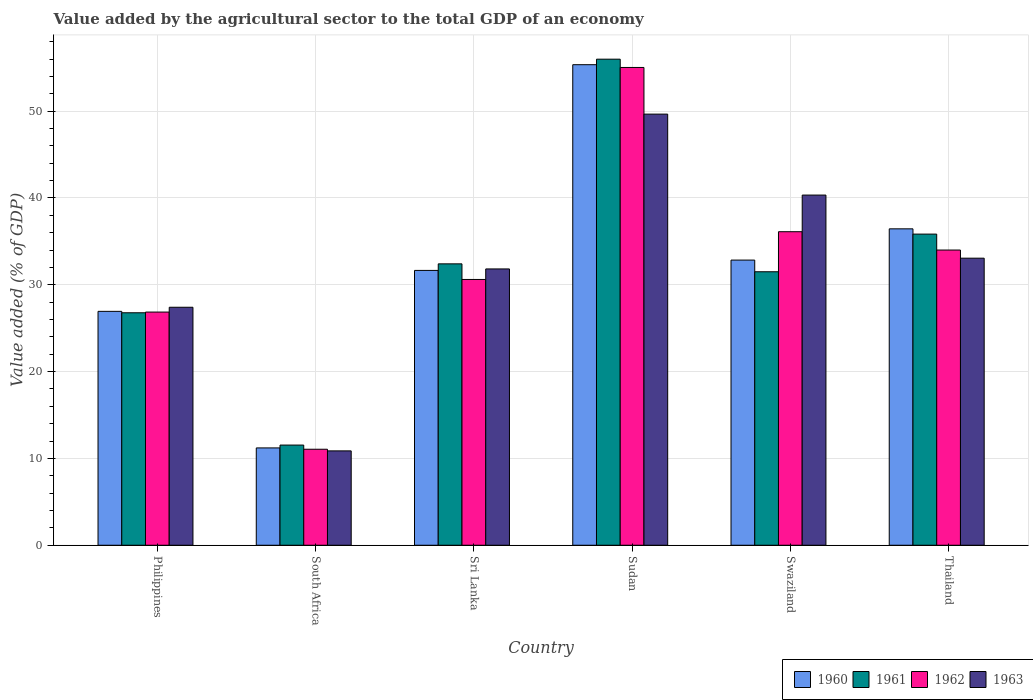How many different coloured bars are there?
Keep it short and to the point. 4. How many groups of bars are there?
Give a very brief answer. 6. Are the number of bars per tick equal to the number of legend labels?
Provide a short and direct response. Yes. Are the number of bars on each tick of the X-axis equal?
Your answer should be compact. Yes. How many bars are there on the 6th tick from the right?
Give a very brief answer. 4. What is the label of the 4th group of bars from the left?
Keep it short and to the point. Sudan. In how many cases, is the number of bars for a given country not equal to the number of legend labels?
Provide a succinct answer. 0. What is the value added by the agricultural sector to the total GDP in 1961 in Sri Lanka?
Provide a short and direct response. 32.41. Across all countries, what is the maximum value added by the agricultural sector to the total GDP in 1960?
Make the answer very short. 55.35. Across all countries, what is the minimum value added by the agricultural sector to the total GDP in 1960?
Provide a succinct answer. 11.21. In which country was the value added by the agricultural sector to the total GDP in 1960 maximum?
Give a very brief answer. Sudan. In which country was the value added by the agricultural sector to the total GDP in 1962 minimum?
Your response must be concise. South Africa. What is the total value added by the agricultural sector to the total GDP in 1960 in the graph?
Make the answer very short. 194.45. What is the difference between the value added by the agricultural sector to the total GDP in 1960 in Sudan and that in Swaziland?
Your answer should be very brief. 22.51. What is the difference between the value added by the agricultural sector to the total GDP in 1961 in Philippines and the value added by the agricultural sector to the total GDP in 1960 in South Africa?
Your answer should be very brief. 15.57. What is the average value added by the agricultural sector to the total GDP in 1960 per country?
Offer a very short reply. 32.41. What is the difference between the value added by the agricultural sector to the total GDP of/in 1962 and value added by the agricultural sector to the total GDP of/in 1963 in Swaziland?
Keep it short and to the point. -4.22. What is the ratio of the value added by the agricultural sector to the total GDP in 1962 in South Africa to that in Swaziland?
Offer a very short reply. 0.31. Is the value added by the agricultural sector to the total GDP in 1962 in Sri Lanka less than that in Thailand?
Your answer should be very brief. Yes. Is the difference between the value added by the agricultural sector to the total GDP in 1962 in Sri Lanka and Thailand greater than the difference between the value added by the agricultural sector to the total GDP in 1963 in Sri Lanka and Thailand?
Provide a short and direct response. No. What is the difference between the highest and the second highest value added by the agricultural sector to the total GDP in 1962?
Make the answer very short. -2.11. What is the difference between the highest and the lowest value added by the agricultural sector to the total GDP in 1963?
Make the answer very short. 38.79. In how many countries, is the value added by the agricultural sector to the total GDP in 1963 greater than the average value added by the agricultural sector to the total GDP in 1963 taken over all countries?
Provide a short and direct response. 3. Is the sum of the value added by the agricultural sector to the total GDP in 1960 in Philippines and Swaziland greater than the maximum value added by the agricultural sector to the total GDP in 1963 across all countries?
Offer a terse response. Yes. What does the 1st bar from the left in Sri Lanka represents?
Your answer should be very brief. 1960. What does the 2nd bar from the right in Thailand represents?
Your answer should be very brief. 1962. What is the difference between two consecutive major ticks on the Y-axis?
Your answer should be compact. 10. Does the graph contain any zero values?
Ensure brevity in your answer.  No. Where does the legend appear in the graph?
Provide a succinct answer. Bottom right. What is the title of the graph?
Keep it short and to the point. Value added by the agricultural sector to the total GDP of an economy. What is the label or title of the Y-axis?
Provide a short and direct response. Value added (% of GDP). What is the Value added (% of GDP) of 1960 in Philippines?
Offer a very short reply. 26.94. What is the Value added (% of GDP) in 1961 in Philippines?
Make the answer very short. 26.78. What is the Value added (% of GDP) in 1962 in Philippines?
Give a very brief answer. 26.86. What is the Value added (% of GDP) of 1963 in Philippines?
Your answer should be very brief. 27.41. What is the Value added (% of GDP) of 1960 in South Africa?
Ensure brevity in your answer.  11.21. What is the Value added (% of GDP) of 1961 in South Africa?
Make the answer very short. 11.54. What is the Value added (% of GDP) in 1962 in South Africa?
Ensure brevity in your answer.  11.06. What is the Value added (% of GDP) in 1963 in South Africa?
Ensure brevity in your answer.  10.87. What is the Value added (% of GDP) of 1960 in Sri Lanka?
Your answer should be very brief. 31.66. What is the Value added (% of GDP) in 1961 in Sri Lanka?
Offer a very short reply. 32.41. What is the Value added (% of GDP) in 1962 in Sri Lanka?
Your answer should be very brief. 30.61. What is the Value added (% of GDP) in 1963 in Sri Lanka?
Offer a terse response. 31.83. What is the Value added (% of GDP) of 1960 in Sudan?
Your answer should be compact. 55.35. What is the Value added (% of GDP) of 1961 in Sudan?
Make the answer very short. 55.99. What is the Value added (% of GDP) of 1962 in Sudan?
Your answer should be compact. 55.03. What is the Value added (% of GDP) in 1963 in Sudan?
Offer a terse response. 49.66. What is the Value added (% of GDP) in 1960 in Swaziland?
Make the answer very short. 32.84. What is the Value added (% of GDP) in 1961 in Swaziland?
Ensure brevity in your answer.  31.5. What is the Value added (% of GDP) in 1962 in Swaziland?
Offer a terse response. 36.11. What is the Value added (% of GDP) of 1963 in Swaziland?
Ensure brevity in your answer.  40.33. What is the Value added (% of GDP) of 1960 in Thailand?
Offer a very short reply. 36.44. What is the Value added (% of GDP) in 1961 in Thailand?
Keep it short and to the point. 35.84. What is the Value added (% of GDP) in 1962 in Thailand?
Offer a very short reply. 34. What is the Value added (% of GDP) in 1963 in Thailand?
Your answer should be compact. 33.07. Across all countries, what is the maximum Value added (% of GDP) in 1960?
Keep it short and to the point. 55.35. Across all countries, what is the maximum Value added (% of GDP) in 1961?
Keep it short and to the point. 55.99. Across all countries, what is the maximum Value added (% of GDP) in 1962?
Make the answer very short. 55.03. Across all countries, what is the maximum Value added (% of GDP) in 1963?
Give a very brief answer. 49.66. Across all countries, what is the minimum Value added (% of GDP) in 1960?
Give a very brief answer. 11.21. Across all countries, what is the minimum Value added (% of GDP) of 1961?
Make the answer very short. 11.54. Across all countries, what is the minimum Value added (% of GDP) of 1962?
Your answer should be very brief. 11.06. Across all countries, what is the minimum Value added (% of GDP) in 1963?
Keep it short and to the point. 10.87. What is the total Value added (% of GDP) in 1960 in the graph?
Make the answer very short. 194.45. What is the total Value added (% of GDP) in 1961 in the graph?
Ensure brevity in your answer.  194.05. What is the total Value added (% of GDP) of 1962 in the graph?
Provide a succinct answer. 193.68. What is the total Value added (% of GDP) in 1963 in the graph?
Offer a very short reply. 193.16. What is the difference between the Value added (% of GDP) in 1960 in Philippines and that in South Africa?
Make the answer very short. 15.73. What is the difference between the Value added (% of GDP) of 1961 in Philippines and that in South Africa?
Offer a terse response. 15.24. What is the difference between the Value added (% of GDP) in 1962 in Philippines and that in South Africa?
Make the answer very short. 15.8. What is the difference between the Value added (% of GDP) in 1963 in Philippines and that in South Africa?
Provide a short and direct response. 16.54. What is the difference between the Value added (% of GDP) of 1960 in Philippines and that in Sri Lanka?
Keep it short and to the point. -4.72. What is the difference between the Value added (% of GDP) in 1961 in Philippines and that in Sri Lanka?
Provide a succinct answer. -5.63. What is the difference between the Value added (% of GDP) of 1962 in Philippines and that in Sri Lanka?
Offer a very short reply. -3.76. What is the difference between the Value added (% of GDP) in 1963 in Philippines and that in Sri Lanka?
Your answer should be very brief. -4.41. What is the difference between the Value added (% of GDP) in 1960 in Philippines and that in Sudan?
Keep it short and to the point. -28.41. What is the difference between the Value added (% of GDP) of 1961 in Philippines and that in Sudan?
Your answer should be compact. -29.21. What is the difference between the Value added (% of GDP) of 1962 in Philippines and that in Sudan?
Ensure brevity in your answer.  -28.18. What is the difference between the Value added (% of GDP) in 1963 in Philippines and that in Sudan?
Provide a short and direct response. -22.25. What is the difference between the Value added (% of GDP) of 1960 in Philippines and that in Swaziland?
Ensure brevity in your answer.  -5.9. What is the difference between the Value added (% of GDP) of 1961 in Philippines and that in Swaziland?
Keep it short and to the point. -4.72. What is the difference between the Value added (% of GDP) of 1962 in Philippines and that in Swaziland?
Offer a very short reply. -9.26. What is the difference between the Value added (% of GDP) in 1963 in Philippines and that in Swaziland?
Make the answer very short. -12.92. What is the difference between the Value added (% of GDP) in 1960 in Philippines and that in Thailand?
Ensure brevity in your answer.  -9.5. What is the difference between the Value added (% of GDP) of 1961 in Philippines and that in Thailand?
Keep it short and to the point. -9.06. What is the difference between the Value added (% of GDP) in 1962 in Philippines and that in Thailand?
Keep it short and to the point. -7.14. What is the difference between the Value added (% of GDP) in 1963 in Philippines and that in Thailand?
Provide a short and direct response. -5.65. What is the difference between the Value added (% of GDP) of 1960 in South Africa and that in Sri Lanka?
Keep it short and to the point. -20.45. What is the difference between the Value added (% of GDP) of 1961 in South Africa and that in Sri Lanka?
Make the answer very short. -20.87. What is the difference between the Value added (% of GDP) of 1962 in South Africa and that in Sri Lanka?
Provide a short and direct response. -19.56. What is the difference between the Value added (% of GDP) of 1963 in South Africa and that in Sri Lanka?
Your answer should be very brief. -20.96. What is the difference between the Value added (% of GDP) of 1960 in South Africa and that in Sudan?
Give a very brief answer. -44.14. What is the difference between the Value added (% of GDP) of 1961 in South Africa and that in Sudan?
Give a very brief answer. -44.45. What is the difference between the Value added (% of GDP) in 1962 in South Africa and that in Sudan?
Ensure brevity in your answer.  -43.98. What is the difference between the Value added (% of GDP) in 1963 in South Africa and that in Sudan?
Provide a succinct answer. -38.79. What is the difference between the Value added (% of GDP) of 1960 in South Africa and that in Swaziland?
Your answer should be very brief. -21.63. What is the difference between the Value added (% of GDP) of 1961 in South Africa and that in Swaziland?
Your answer should be very brief. -19.96. What is the difference between the Value added (% of GDP) in 1962 in South Africa and that in Swaziland?
Your answer should be compact. -25.06. What is the difference between the Value added (% of GDP) in 1963 in South Africa and that in Swaziland?
Your answer should be very brief. -29.46. What is the difference between the Value added (% of GDP) in 1960 in South Africa and that in Thailand?
Give a very brief answer. -25.23. What is the difference between the Value added (% of GDP) of 1961 in South Africa and that in Thailand?
Your answer should be very brief. -24.3. What is the difference between the Value added (% of GDP) of 1962 in South Africa and that in Thailand?
Offer a terse response. -22.95. What is the difference between the Value added (% of GDP) of 1963 in South Africa and that in Thailand?
Provide a succinct answer. -22.2. What is the difference between the Value added (% of GDP) in 1960 in Sri Lanka and that in Sudan?
Offer a terse response. -23.7. What is the difference between the Value added (% of GDP) of 1961 in Sri Lanka and that in Sudan?
Offer a terse response. -23.58. What is the difference between the Value added (% of GDP) in 1962 in Sri Lanka and that in Sudan?
Make the answer very short. -24.42. What is the difference between the Value added (% of GDP) of 1963 in Sri Lanka and that in Sudan?
Offer a very short reply. -17.83. What is the difference between the Value added (% of GDP) in 1960 in Sri Lanka and that in Swaziland?
Keep it short and to the point. -1.19. What is the difference between the Value added (% of GDP) of 1961 in Sri Lanka and that in Swaziland?
Offer a terse response. 0.91. What is the difference between the Value added (% of GDP) of 1962 in Sri Lanka and that in Swaziland?
Provide a succinct answer. -5.5. What is the difference between the Value added (% of GDP) in 1963 in Sri Lanka and that in Swaziland?
Offer a terse response. -8.51. What is the difference between the Value added (% of GDP) of 1960 in Sri Lanka and that in Thailand?
Your response must be concise. -4.79. What is the difference between the Value added (% of GDP) of 1961 in Sri Lanka and that in Thailand?
Ensure brevity in your answer.  -3.43. What is the difference between the Value added (% of GDP) of 1962 in Sri Lanka and that in Thailand?
Your answer should be very brief. -3.39. What is the difference between the Value added (% of GDP) in 1963 in Sri Lanka and that in Thailand?
Provide a short and direct response. -1.24. What is the difference between the Value added (% of GDP) of 1960 in Sudan and that in Swaziland?
Your response must be concise. 22.51. What is the difference between the Value added (% of GDP) in 1961 in Sudan and that in Swaziland?
Your answer should be compact. 24.49. What is the difference between the Value added (% of GDP) of 1962 in Sudan and that in Swaziland?
Provide a succinct answer. 18.92. What is the difference between the Value added (% of GDP) of 1963 in Sudan and that in Swaziland?
Ensure brevity in your answer.  9.32. What is the difference between the Value added (% of GDP) in 1960 in Sudan and that in Thailand?
Your answer should be compact. 18.91. What is the difference between the Value added (% of GDP) of 1961 in Sudan and that in Thailand?
Your response must be concise. 20.15. What is the difference between the Value added (% of GDP) of 1962 in Sudan and that in Thailand?
Provide a succinct answer. 21.03. What is the difference between the Value added (% of GDP) in 1963 in Sudan and that in Thailand?
Your answer should be very brief. 16.59. What is the difference between the Value added (% of GDP) of 1960 in Swaziland and that in Thailand?
Provide a succinct answer. -3.6. What is the difference between the Value added (% of GDP) of 1961 in Swaziland and that in Thailand?
Ensure brevity in your answer.  -4.34. What is the difference between the Value added (% of GDP) in 1962 in Swaziland and that in Thailand?
Offer a very short reply. 2.11. What is the difference between the Value added (% of GDP) in 1963 in Swaziland and that in Thailand?
Your answer should be compact. 7.27. What is the difference between the Value added (% of GDP) of 1960 in Philippines and the Value added (% of GDP) of 1961 in South Africa?
Your answer should be compact. 15.4. What is the difference between the Value added (% of GDP) of 1960 in Philippines and the Value added (% of GDP) of 1962 in South Africa?
Your answer should be very brief. 15.88. What is the difference between the Value added (% of GDP) of 1960 in Philippines and the Value added (% of GDP) of 1963 in South Africa?
Make the answer very short. 16.07. What is the difference between the Value added (% of GDP) in 1961 in Philippines and the Value added (% of GDP) in 1962 in South Africa?
Make the answer very short. 15.72. What is the difference between the Value added (% of GDP) of 1961 in Philippines and the Value added (% of GDP) of 1963 in South Africa?
Your answer should be compact. 15.91. What is the difference between the Value added (% of GDP) of 1962 in Philippines and the Value added (% of GDP) of 1963 in South Africa?
Provide a short and direct response. 15.99. What is the difference between the Value added (% of GDP) of 1960 in Philippines and the Value added (% of GDP) of 1961 in Sri Lanka?
Make the answer very short. -5.47. What is the difference between the Value added (% of GDP) of 1960 in Philippines and the Value added (% of GDP) of 1962 in Sri Lanka?
Your answer should be very brief. -3.67. What is the difference between the Value added (% of GDP) in 1960 in Philippines and the Value added (% of GDP) in 1963 in Sri Lanka?
Provide a succinct answer. -4.89. What is the difference between the Value added (% of GDP) of 1961 in Philippines and the Value added (% of GDP) of 1962 in Sri Lanka?
Make the answer very short. -3.84. What is the difference between the Value added (% of GDP) in 1961 in Philippines and the Value added (% of GDP) in 1963 in Sri Lanka?
Give a very brief answer. -5.05. What is the difference between the Value added (% of GDP) of 1962 in Philippines and the Value added (% of GDP) of 1963 in Sri Lanka?
Ensure brevity in your answer.  -4.97. What is the difference between the Value added (% of GDP) in 1960 in Philippines and the Value added (% of GDP) in 1961 in Sudan?
Your response must be concise. -29.05. What is the difference between the Value added (% of GDP) in 1960 in Philippines and the Value added (% of GDP) in 1962 in Sudan?
Provide a succinct answer. -28.09. What is the difference between the Value added (% of GDP) of 1960 in Philippines and the Value added (% of GDP) of 1963 in Sudan?
Offer a terse response. -22.72. What is the difference between the Value added (% of GDP) of 1961 in Philippines and the Value added (% of GDP) of 1962 in Sudan?
Give a very brief answer. -28.26. What is the difference between the Value added (% of GDP) in 1961 in Philippines and the Value added (% of GDP) in 1963 in Sudan?
Keep it short and to the point. -22.88. What is the difference between the Value added (% of GDP) in 1962 in Philippines and the Value added (% of GDP) in 1963 in Sudan?
Your response must be concise. -22.8. What is the difference between the Value added (% of GDP) of 1960 in Philippines and the Value added (% of GDP) of 1961 in Swaziland?
Ensure brevity in your answer.  -4.56. What is the difference between the Value added (% of GDP) of 1960 in Philippines and the Value added (% of GDP) of 1962 in Swaziland?
Make the answer very short. -9.17. What is the difference between the Value added (% of GDP) in 1960 in Philippines and the Value added (% of GDP) in 1963 in Swaziland?
Make the answer very short. -13.39. What is the difference between the Value added (% of GDP) in 1961 in Philippines and the Value added (% of GDP) in 1962 in Swaziland?
Provide a succinct answer. -9.34. What is the difference between the Value added (% of GDP) in 1961 in Philippines and the Value added (% of GDP) in 1963 in Swaziland?
Provide a short and direct response. -13.56. What is the difference between the Value added (% of GDP) in 1962 in Philippines and the Value added (% of GDP) in 1963 in Swaziland?
Provide a succinct answer. -13.48. What is the difference between the Value added (% of GDP) of 1960 in Philippines and the Value added (% of GDP) of 1961 in Thailand?
Keep it short and to the point. -8.9. What is the difference between the Value added (% of GDP) in 1960 in Philippines and the Value added (% of GDP) in 1962 in Thailand?
Your response must be concise. -7.06. What is the difference between the Value added (% of GDP) in 1960 in Philippines and the Value added (% of GDP) in 1963 in Thailand?
Your response must be concise. -6.12. What is the difference between the Value added (% of GDP) in 1961 in Philippines and the Value added (% of GDP) in 1962 in Thailand?
Provide a short and direct response. -7.23. What is the difference between the Value added (% of GDP) of 1961 in Philippines and the Value added (% of GDP) of 1963 in Thailand?
Make the answer very short. -6.29. What is the difference between the Value added (% of GDP) in 1962 in Philippines and the Value added (% of GDP) in 1963 in Thailand?
Your response must be concise. -6.21. What is the difference between the Value added (% of GDP) in 1960 in South Africa and the Value added (% of GDP) in 1961 in Sri Lanka?
Give a very brief answer. -21.2. What is the difference between the Value added (% of GDP) in 1960 in South Africa and the Value added (% of GDP) in 1962 in Sri Lanka?
Offer a terse response. -19.4. What is the difference between the Value added (% of GDP) in 1960 in South Africa and the Value added (% of GDP) in 1963 in Sri Lanka?
Make the answer very short. -20.62. What is the difference between the Value added (% of GDP) of 1961 in South Africa and the Value added (% of GDP) of 1962 in Sri Lanka?
Provide a short and direct response. -19.08. What is the difference between the Value added (% of GDP) in 1961 in South Africa and the Value added (% of GDP) in 1963 in Sri Lanka?
Keep it short and to the point. -20.29. What is the difference between the Value added (% of GDP) in 1962 in South Africa and the Value added (% of GDP) in 1963 in Sri Lanka?
Provide a short and direct response. -20.77. What is the difference between the Value added (% of GDP) in 1960 in South Africa and the Value added (% of GDP) in 1961 in Sudan?
Give a very brief answer. -44.78. What is the difference between the Value added (% of GDP) in 1960 in South Africa and the Value added (% of GDP) in 1962 in Sudan?
Give a very brief answer. -43.82. What is the difference between the Value added (% of GDP) in 1960 in South Africa and the Value added (% of GDP) in 1963 in Sudan?
Your response must be concise. -38.45. What is the difference between the Value added (% of GDP) of 1961 in South Africa and the Value added (% of GDP) of 1962 in Sudan?
Your answer should be compact. -43.5. What is the difference between the Value added (% of GDP) in 1961 in South Africa and the Value added (% of GDP) in 1963 in Sudan?
Offer a terse response. -38.12. What is the difference between the Value added (% of GDP) of 1962 in South Africa and the Value added (% of GDP) of 1963 in Sudan?
Provide a short and direct response. -38.6. What is the difference between the Value added (% of GDP) of 1960 in South Africa and the Value added (% of GDP) of 1961 in Swaziland?
Keep it short and to the point. -20.29. What is the difference between the Value added (% of GDP) in 1960 in South Africa and the Value added (% of GDP) in 1962 in Swaziland?
Provide a succinct answer. -24.9. What is the difference between the Value added (% of GDP) of 1960 in South Africa and the Value added (% of GDP) of 1963 in Swaziland?
Offer a very short reply. -29.12. What is the difference between the Value added (% of GDP) of 1961 in South Africa and the Value added (% of GDP) of 1962 in Swaziland?
Your answer should be compact. -24.58. What is the difference between the Value added (% of GDP) in 1961 in South Africa and the Value added (% of GDP) in 1963 in Swaziland?
Ensure brevity in your answer.  -28.8. What is the difference between the Value added (% of GDP) of 1962 in South Africa and the Value added (% of GDP) of 1963 in Swaziland?
Your response must be concise. -29.28. What is the difference between the Value added (% of GDP) of 1960 in South Africa and the Value added (% of GDP) of 1961 in Thailand?
Keep it short and to the point. -24.63. What is the difference between the Value added (% of GDP) in 1960 in South Africa and the Value added (% of GDP) in 1962 in Thailand?
Your answer should be very brief. -22.79. What is the difference between the Value added (% of GDP) in 1960 in South Africa and the Value added (% of GDP) in 1963 in Thailand?
Your response must be concise. -21.86. What is the difference between the Value added (% of GDP) in 1961 in South Africa and the Value added (% of GDP) in 1962 in Thailand?
Ensure brevity in your answer.  -22.47. What is the difference between the Value added (% of GDP) of 1961 in South Africa and the Value added (% of GDP) of 1963 in Thailand?
Your answer should be very brief. -21.53. What is the difference between the Value added (% of GDP) of 1962 in South Africa and the Value added (% of GDP) of 1963 in Thailand?
Offer a very short reply. -22.01. What is the difference between the Value added (% of GDP) of 1960 in Sri Lanka and the Value added (% of GDP) of 1961 in Sudan?
Offer a terse response. -24.33. What is the difference between the Value added (% of GDP) of 1960 in Sri Lanka and the Value added (% of GDP) of 1962 in Sudan?
Your answer should be compact. -23.38. What is the difference between the Value added (% of GDP) of 1960 in Sri Lanka and the Value added (% of GDP) of 1963 in Sudan?
Your response must be concise. -18. What is the difference between the Value added (% of GDP) in 1961 in Sri Lanka and the Value added (% of GDP) in 1962 in Sudan?
Make the answer very short. -22.62. What is the difference between the Value added (% of GDP) of 1961 in Sri Lanka and the Value added (% of GDP) of 1963 in Sudan?
Your answer should be very brief. -17.25. What is the difference between the Value added (% of GDP) of 1962 in Sri Lanka and the Value added (% of GDP) of 1963 in Sudan?
Ensure brevity in your answer.  -19.04. What is the difference between the Value added (% of GDP) of 1960 in Sri Lanka and the Value added (% of GDP) of 1961 in Swaziland?
Your answer should be compact. 0.16. What is the difference between the Value added (% of GDP) of 1960 in Sri Lanka and the Value added (% of GDP) of 1962 in Swaziland?
Your answer should be very brief. -4.46. What is the difference between the Value added (% of GDP) in 1960 in Sri Lanka and the Value added (% of GDP) in 1963 in Swaziland?
Your answer should be compact. -8.68. What is the difference between the Value added (% of GDP) in 1961 in Sri Lanka and the Value added (% of GDP) in 1962 in Swaziland?
Your answer should be very brief. -3.7. What is the difference between the Value added (% of GDP) of 1961 in Sri Lanka and the Value added (% of GDP) of 1963 in Swaziland?
Provide a succinct answer. -7.92. What is the difference between the Value added (% of GDP) in 1962 in Sri Lanka and the Value added (% of GDP) in 1963 in Swaziland?
Your response must be concise. -9.72. What is the difference between the Value added (% of GDP) of 1960 in Sri Lanka and the Value added (% of GDP) of 1961 in Thailand?
Offer a very short reply. -4.18. What is the difference between the Value added (% of GDP) in 1960 in Sri Lanka and the Value added (% of GDP) in 1962 in Thailand?
Offer a terse response. -2.35. What is the difference between the Value added (% of GDP) in 1960 in Sri Lanka and the Value added (% of GDP) in 1963 in Thailand?
Your answer should be compact. -1.41. What is the difference between the Value added (% of GDP) in 1961 in Sri Lanka and the Value added (% of GDP) in 1962 in Thailand?
Keep it short and to the point. -1.59. What is the difference between the Value added (% of GDP) of 1961 in Sri Lanka and the Value added (% of GDP) of 1963 in Thailand?
Provide a succinct answer. -0.65. What is the difference between the Value added (% of GDP) in 1962 in Sri Lanka and the Value added (% of GDP) in 1963 in Thailand?
Make the answer very short. -2.45. What is the difference between the Value added (% of GDP) of 1960 in Sudan and the Value added (% of GDP) of 1961 in Swaziland?
Offer a very short reply. 23.85. What is the difference between the Value added (% of GDP) of 1960 in Sudan and the Value added (% of GDP) of 1962 in Swaziland?
Give a very brief answer. 19.24. What is the difference between the Value added (% of GDP) in 1960 in Sudan and the Value added (% of GDP) in 1963 in Swaziland?
Your answer should be very brief. 15.02. What is the difference between the Value added (% of GDP) of 1961 in Sudan and the Value added (% of GDP) of 1962 in Swaziland?
Keep it short and to the point. 19.87. What is the difference between the Value added (% of GDP) in 1961 in Sudan and the Value added (% of GDP) in 1963 in Swaziland?
Keep it short and to the point. 15.65. What is the difference between the Value added (% of GDP) of 1962 in Sudan and the Value added (% of GDP) of 1963 in Swaziland?
Give a very brief answer. 14.7. What is the difference between the Value added (% of GDP) of 1960 in Sudan and the Value added (% of GDP) of 1961 in Thailand?
Keep it short and to the point. 19.51. What is the difference between the Value added (% of GDP) in 1960 in Sudan and the Value added (% of GDP) in 1962 in Thailand?
Your answer should be very brief. 21.35. What is the difference between the Value added (% of GDP) in 1960 in Sudan and the Value added (% of GDP) in 1963 in Thailand?
Keep it short and to the point. 22.29. What is the difference between the Value added (% of GDP) of 1961 in Sudan and the Value added (% of GDP) of 1962 in Thailand?
Provide a short and direct response. 21.98. What is the difference between the Value added (% of GDP) in 1961 in Sudan and the Value added (% of GDP) in 1963 in Thailand?
Provide a succinct answer. 22.92. What is the difference between the Value added (% of GDP) in 1962 in Sudan and the Value added (% of GDP) in 1963 in Thailand?
Your answer should be compact. 21.97. What is the difference between the Value added (% of GDP) in 1960 in Swaziland and the Value added (% of GDP) in 1961 in Thailand?
Provide a short and direct response. -2.99. What is the difference between the Value added (% of GDP) in 1960 in Swaziland and the Value added (% of GDP) in 1962 in Thailand?
Keep it short and to the point. -1.16. What is the difference between the Value added (% of GDP) in 1960 in Swaziland and the Value added (% of GDP) in 1963 in Thailand?
Offer a terse response. -0.22. What is the difference between the Value added (% of GDP) in 1961 in Swaziland and the Value added (% of GDP) in 1962 in Thailand?
Your answer should be very brief. -2.5. What is the difference between the Value added (% of GDP) in 1961 in Swaziland and the Value added (% of GDP) in 1963 in Thailand?
Your response must be concise. -1.57. What is the difference between the Value added (% of GDP) in 1962 in Swaziland and the Value added (% of GDP) in 1963 in Thailand?
Make the answer very short. 3.05. What is the average Value added (% of GDP) of 1960 per country?
Give a very brief answer. 32.41. What is the average Value added (% of GDP) of 1961 per country?
Provide a succinct answer. 32.34. What is the average Value added (% of GDP) of 1962 per country?
Offer a very short reply. 32.28. What is the average Value added (% of GDP) in 1963 per country?
Your answer should be compact. 32.19. What is the difference between the Value added (% of GDP) of 1960 and Value added (% of GDP) of 1961 in Philippines?
Your answer should be very brief. 0.16. What is the difference between the Value added (% of GDP) in 1960 and Value added (% of GDP) in 1962 in Philippines?
Your response must be concise. 0.08. What is the difference between the Value added (% of GDP) of 1960 and Value added (% of GDP) of 1963 in Philippines?
Offer a terse response. -0.47. What is the difference between the Value added (% of GDP) in 1961 and Value added (% of GDP) in 1962 in Philippines?
Give a very brief answer. -0.08. What is the difference between the Value added (% of GDP) in 1961 and Value added (% of GDP) in 1963 in Philippines?
Provide a succinct answer. -0.64. What is the difference between the Value added (% of GDP) in 1962 and Value added (% of GDP) in 1963 in Philippines?
Your answer should be very brief. -0.55. What is the difference between the Value added (% of GDP) of 1960 and Value added (% of GDP) of 1961 in South Africa?
Keep it short and to the point. -0.33. What is the difference between the Value added (% of GDP) of 1960 and Value added (% of GDP) of 1962 in South Africa?
Your answer should be compact. 0.15. What is the difference between the Value added (% of GDP) of 1960 and Value added (% of GDP) of 1963 in South Africa?
Keep it short and to the point. 0.34. What is the difference between the Value added (% of GDP) of 1961 and Value added (% of GDP) of 1962 in South Africa?
Offer a terse response. 0.48. What is the difference between the Value added (% of GDP) of 1961 and Value added (% of GDP) of 1963 in South Africa?
Offer a terse response. 0.67. What is the difference between the Value added (% of GDP) in 1962 and Value added (% of GDP) in 1963 in South Africa?
Offer a terse response. 0.19. What is the difference between the Value added (% of GDP) of 1960 and Value added (% of GDP) of 1961 in Sri Lanka?
Ensure brevity in your answer.  -0.76. What is the difference between the Value added (% of GDP) of 1960 and Value added (% of GDP) of 1962 in Sri Lanka?
Provide a short and direct response. 1.04. What is the difference between the Value added (% of GDP) in 1960 and Value added (% of GDP) in 1963 in Sri Lanka?
Keep it short and to the point. -0.17. What is the difference between the Value added (% of GDP) in 1961 and Value added (% of GDP) in 1962 in Sri Lanka?
Your answer should be very brief. 1.8. What is the difference between the Value added (% of GDP) in 1961 and Value added (% of GDP) in 1963 in Sri Lanka?
Give a very brief answer. 0.59. What is the difference between the Value added (% of GDP) of 1962 and Value added (% of GDP) of 1963 in Sri Lanka?
Offer a terse response. -1.21. What is the difference between the Value added (% of GDP) in 1960 and Value added (% of GDP) in 1961 in Sudan?
Offer a terse response. -0.64. What is the difference between the Value added (% of GDP) in 1960 and Value added (% of GDP) in 1962 in Sudan?
Offer a terse response. 0.32. What is the difference between the Value added (% of GDP) in 1960 and Value added (% of GDP) in 1963 in Sudan?
Your response must be concise. 5.69. What is the difference between the Value added (% of GDP) in 1961 and Value added (% of GDP) in 1962 in Sudan?
Give a very brief answer. 0.95. What is the difference between the Value added (% of GDP) of 1961 and Value added (% of GDP) of 1963 in Sudan?
Provide a short and direct response. 6.33. What is the difference between the Value added (% of GDP) of 1962 and Value added (% of GDP) of 1963 in Sudan?
Your answer should be compact. 5.37. What is the difference between the Value added (% of GDP) of 1960 and Value added (% of GDP) of 1961 in Swaziland?
Give a very brief answer. 1.35. What is the difference between the Value added (% of GDP) of 1960 and Value added (% of GDP) of 1962 in Swaziland?
Provide a succinct answer. -3.27. What is the difference between the Value added (% of GDP) in 1960 and Value added (% of GDP) in 1963 in Swaziland?
Your answer should be very brief. -7.49. What is the difference between the Value added (% of GDP) of 1961 and Value added (% of GDP) of 1962 in Swaziland?
Your answer should be very brief. -4.61. What is the difference between the Value added (% of GDP) of 1961 and Value added (% of GDP) of 1963 in Swaziland?
Make the answer very short. -8.83. What is the difference between the Value added (% of GDP) in 1962 and Value added (% of GDP) in 1963 in Swaziland?
Offer a very short reply. -4.22. What is the difference between the Value added (% of GDP) of 1960 and Value added (% of GDP) of 1961 in Thailand?
Provide a short and direct response. 0.61. What is the difference between the Value added (% of GDP) in 1960 and Value added (% of GDP) in 1962 in Thailand?
Offer a very short reply. 2.44. What is the difference between the Value added (% of GDP) of 1960 and Value added (% of GDP) of 1963 in Thailand?
Provide a succinct answer. 3.38. What is the difference between the Value added (% of GDP) in 1961 and Value added (% of GDP) in 1962 in Thailand?
Keep it short and to the point. 1.84. What is the difference between the Value added (% of GDP) of 1961 and Value added (% of GDP) of 1963 in Thailand?
Offer a very short reply. 2.77. What is the difference between the Value added (% of GDP) of 1962 and Value added (% of GDP) of 1963 in Thailand?
Give a very brief answer. 0.94. What is the ratio of the Value added (% of GDP) in 1960 in Philippines to that in South Africa?
Provide a short and direct response. 2.4. What is the ratio of the Value added (% of GDP) of 1961 in Philippines to that in South Africa?
Provide a succinct answer. 2.32. What is the ratio of the Value added (% of GDP) of 1962 in Philippines to that in South Africa?
Give a very brief answer. 2.43. What is the ratio of the Value added (% of GDP) in 1963 in Philippines to that in South Africa?
Ensure brevity in your answer.  2.52. What is the ratio of the Value added (% of GDP) in 1960 in Philippines to that in Sri Lanka?
Offer a terse response. 0.85. What is the ratio of the Value added (% of GDP) in 1961 in Philippines to that in Sri Lanka?
Make the answer very short. 0.83. What is the ratio of the Value added (% of GDP) of 1962 in Philippines to that in Sri Lanka?
Make the answer very short. 0.88. What is the ratio of the Value added (% of GDP) of 1963 in Philippines to that in Sri Lanka?
Ensure brevity in your answer.  0.86. What is the ratio of the Value added (% of GDP) of 1960 in Philippines to that in Sudan?
Make the answer very short. 0.49. What is the ratio of the Value added (% of GDP) in 1961 in Philippines to that in Sudan?
Your answer should be very brief. 0.48. What is the ratio of the Value added (% of GDP) of 1962 in Philippines to that in Sudan?
Provide a succinct answer. 0.49. What is the ratio of the Value added (% of GDP) in 1963 in Philippines to that in Sudan?
Give a very brief answer. 0.55. What is the ratio of the Value added (% of GDP) of 1960 in Philippines to that in Swaziland?
Your answer should be compact. 0.82. What is the ratio of the Value added (% of GDP) of 1961 in Philippines to that in Swaziland?
Keep it short and to the point. 0.85. What is the ratio of the Value added (% of GDP) of 1962 in Philippines to that in Swaziland?
Provide a short and direct response. 0.74. What is the ratio of the Value added (% of GDP) in 1963 in Philippines to that in Swaziland?
Offer a terse response. 0.68. What is the ratio of the Value added (% of GDP) in 1960 in Philippines to that in Thailand?
Offer a very short reply. 0.74. What is the ratio of the Value added (% of GDP) of 1961 in Philippines to that in Thailand?
Keep it short and to the point. 0.75. What is the ratio of the Value added (% of GDP) of 1962 in Philippines to that in Thailand?
Ensure brevity in your answer.  0.79. What is the ratio of the Value added (% of GDP) in 1963 in Philippines to that in Thailand?
Offer a very short reply. 0.83. What is the ratio of the Value added (% of GDP) of 1960 in South Africa to that in Sri Lanka?
Your response must be concise. 0.35. What is the ratio of the Value added (% of GDP) in 1961 in South Africa to that in Sri Lanka?
Provide a short and direct response. 0.36. What is the ratio of the Value added (% of GDP) of 1962 in South Africa to that in Sri Lanka?
Provide a succinct answer. 0.36. What is the ratio of the Value added (% of GDP) in 1963 in South Africa to that in Sri Lanka?
Give a very brief answer. 0.34. What is the ratio of the Value added (% of GDP) in 1960 in South Africa to that in Sudan?
Provide a short and direct response. 0.2. What is the ratio of the Value added (% of GDP) of 1961 in South Africa to that in Sudan?
Your answer should be very brief. 0.21. What is the ratio of the Value added (% of GDP) in 1962 in South Africa to that in Sudan?
Your answer should be compact. 0.2. What is the ratio of the Value added (% of GDP) of 1963 in South Africa to that in Sudan?
Make the answer very short. 0.22. What is the ratio of the Value added (% of GDP) of 1960 in South Africa to that in Swaziland?
Ensure brevity in your answer.  0.34. What is the ratio of the Value added (% of GDP) in 1961 in South Africa to that in Swaziland?
Ensure brevity in your answer.  0.37. What is the ratio of the Value added (% of GDP) in 1962 in South Africa to that in Swaziland?
Your answer should be compact. 0.31. What is the ratio of the Value added (% of GDP) in 1963 in South Africa to that in Swaziland?
Make the answer very short. 0.27. What is the ratio of the Value added (% of GDP) in 1960 in South Africa to that in Thailand?
Give a very brief answer. 0.31. What is the ratio of the Value added (% of GDP) in 1961 in South Africa to that in Thailand?
Provide a short and direct response. 0.32. What is the ratio of the Value added (% of GDP) of 1962 in South Africa to that in Thailand?
Your answer should be very brief. 0.33. What is the ratio of the Value added (% of GDP) of 1963 in South Africa to that in Thailand?
Provide a short and direct response. 0.33. What is the ratio of the Value added (% of GDP) of 1960 in Sri Lanka to that in Sudan?
Your response must be concise. 0.57. What is the ratio of the Value added (% of GDP) of 1961 in Sri Lanka to that in Sudan?
Make the answer very short. 0.58. What is the ratio of the Value added (% of GDP) of 1962 in Sri Lanka to that in Sudan?
Provide a short and direct response. 0.56. What is the ratio of the Value added (% of GDP) in 1963 in Sri Lanka to that in Sudan?
Your answer should be compact. 0.64. What is the ratio of the Value added (% of GDP) in 1960 in Sri Lanka to that in Swaziland?
Make the answer very short. 0.96. What is the ratio of the Value added (% of GDP) of 1961 in Sri Lanka to that in Swaziland?
Keep it short and to the point. 1.03. What is the ratio of the Value added (% of GDP) in 1962 in Sri Lanka to that in Swaziland?
Your answer should be compact. 0.85. What is the ratio of the Value added (% of GDP) in 1963 in Sri Lanka to that in Swaziland?
Your response must be concise. 0.79. What is the ratio of the Value added (% of GDP) of 1960 in Sri Lanka to that in Thailand?
Provide a succinct answer. 0.87. What is the ratio of the Value added (% of GDP) of 1961 in Sri Lanka to that in Thailand?
Your answer should be compact. 0.9. What is the ratio of the Value added (% of GDP) of 1962 in Sri Lanka to that in Thailand?
Offer a terse response. 0.9. What is the ratio of the Value added (% of GDP) of 1963 in Sri Lanka to that in Thailand?
Give a very brief answer. 0.96. What is the ratio of the Value added (% of GDP) in 1960 in Sudan to that in Swaziland?
Provide a succinct answer. 1.69. What is the ratio of the Value added (% of GDP) of 1961 in Sudan to that in Swaziland?
Provide a short and direct response. 1.78. What is the ratio of the Value added (% of GDP) in 1962 in Sudan to that in Swaziland?
Make the answer very short. 1.52. What is the ratio of the Value added (% of GDP) of 1963 in Sudan to that in Swaziland?
Your response must be concise. 1.23. What is the ratio of the Value added (% of GDP) of 1960 in Sudan to that in Thailand?
Provide a short and direct response. 1.52. What is the ratio of the Value added (% of GDP) in 1961 in Sudan to that in Thailand?
Your answer should be very brief. 1.56. What is the ratio of the Value added (% of GDP) of 1962 in Sudan to that in Thailand?
Offer a very short reply. 1.62. What is the ratio of the Value added (% of GDP) of 1963 in Sudan to that in Thailand?
Make the answer very short. 1.5. What is the ratio of the Value added (% of GDP) in 1960 in Swaziland to that in Thailand?
Make the answer very short. 0.9. What is the ratio of the Value added (% of GDP) of 1961 in Swaziland to that in Thailand?
Your response must be concise. 0.88. What is the ratio of the Value added (% of GDP) in 1962 in Swaziland to that in Thailand?
Keep it short and to the point. 1.06. What is the ratio of the Value added (% of GDP) of 1963 in Swaziland to that in Thailand?
Your response must be concise. 1.22. What is the difference between the highest and the second highest Value added (% of GDP) in 1960?
Your response must be concise. 18.91. What is the difference between the highest and the second highest Value added (% of GDP) in 1961?
Keep it short and to the point. 20.15. What is the difference between the highest and the second highest Value added (% of GDP) in 1962?
Your answer should be compact. 18.92. What is the difference between the highest and the second highest Value added (% of GDP) in 1963?
Provide a succinct answer. 9.32. What is the difference between the highest and the lowest Value added (% of GDP) in 1960?
Your answer should be compact. 44.14. What is the difference between the highest and the lowest Value added (% of GDP) of 1961?
Your answer should be very brief. 44.45. What is the difference between the highest and the lowest Value added (% of GDP) of 1962?
Provide a short and direct response. 43.98. What is the difference between the highest and the lowest Value added (% of GDP) in 1963?
Keep it short and to the point. 38.79. 